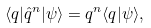<formula> <loc_0><loc_0><loc_500><loc_500>\langle q | \hat { q } ^ { n } | \psi \rangle = q ^ { n } \langle q | \psi \rangle ,</formula> 